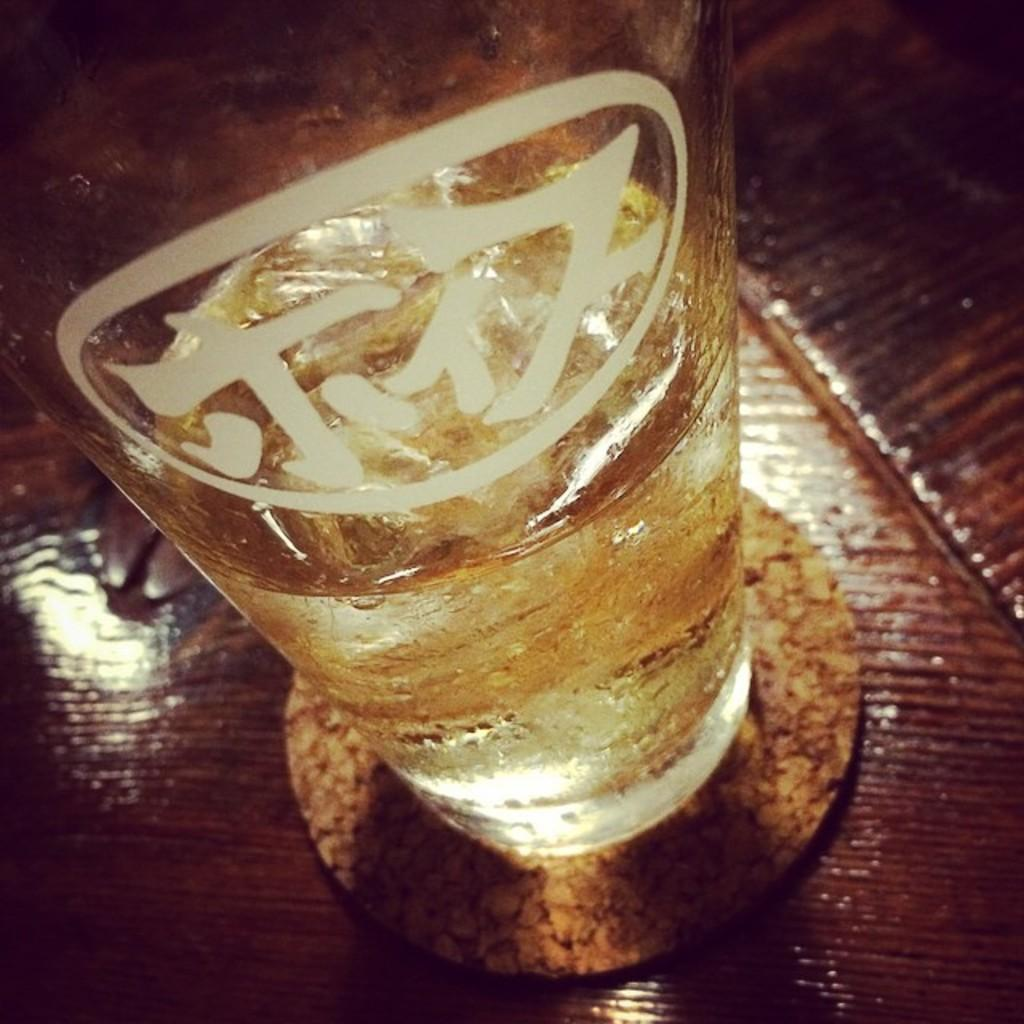What piece of furniture is present in the image? There is a table in the image. What is placed on the table? There is a glass of wine on the table. What is the name of the person sitting at the table in the image? There is no person present in the image, so it is not possible to determine their name. 